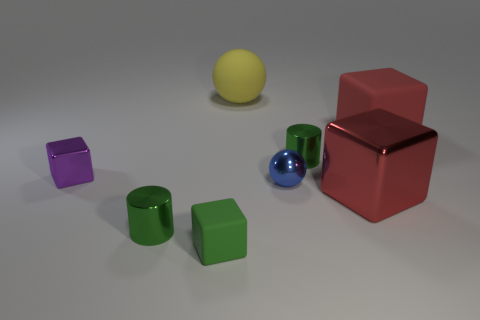Subtract 1 blocks. How many blocks are left? 3 Add 1 blue spheres. How many objects exist? 9 Subtract all cylinders. How many objects are left? 6 Add 3 large rubber balls. How many large rubber balls are left? 4 Add 3 small red rubber blocks. How many small red rubber blocks exist? 3 Subtract 0 yellow cubes. How many objects are left? 8 Subtract all tiny green rubber blocks. Subtract all large metal blocks. How many objects are left? 6 